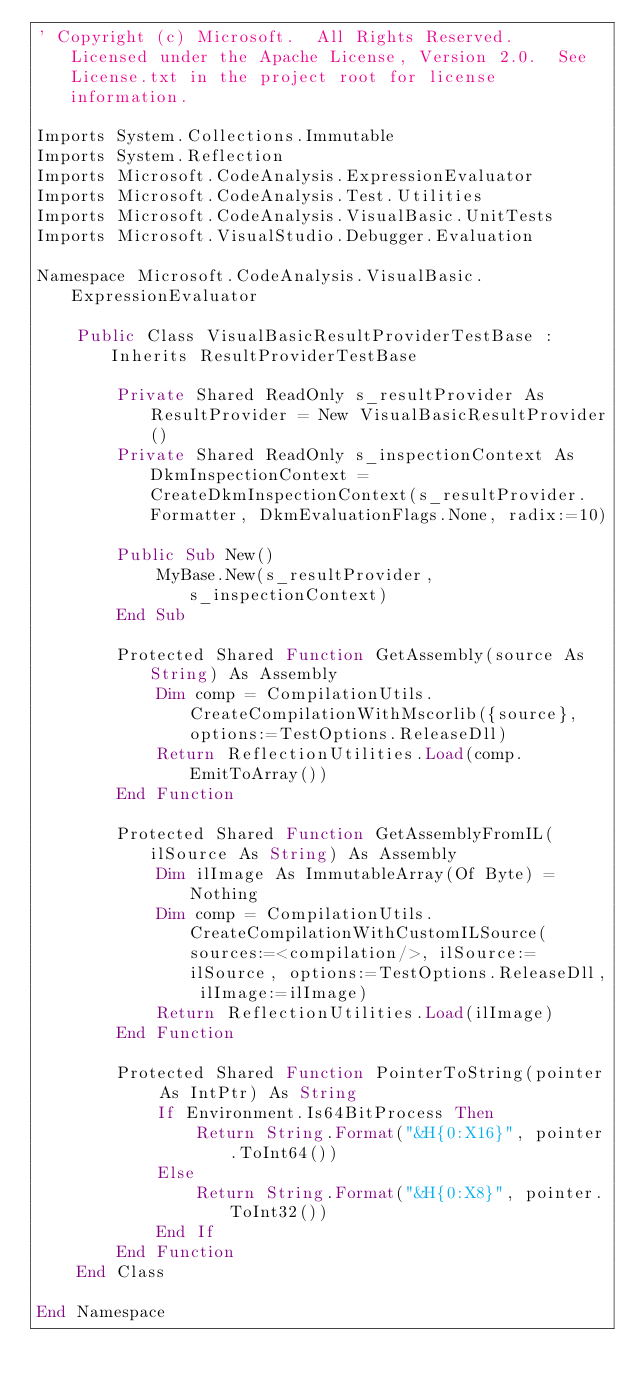Convert code to text. <code><loc_0><loc_0><loc_500><loc_500><_VisualBasic_>' Copyright (c) Microsoft.  All Rights Reserved.  Licensed under the Apache License, Version 2.0.  See License.txt in the project root for license information.

Imports System.Collections.Immutable
Imports System.Reflection
Imports Microsoft.CodeAnalysis.ExpressionEvaluator
Imports Microsoft.CodeAnalysis.Test.Utilities
Imports Microsoft.CodeAnalysis.VisualBasic.UnitTests
Imports Microsoft.VisualStudio.Debugger.Evaluation

Namespace Microsoft.CodeAnalysis.VisualBasic.ExpressionEvaluator

    Public Class VisualBasicResultProviderTestBase : Inherits ResultProviderTestBase

        Private Shared ReadOnly s_resultProvider As ResultProvider = New VisualBasicResultProvider()
        Private Shared ReadOnly s_inspectionContext As DkmInspectionContext = CreateDkmInspectionContext(s_resultProvider.Formatter, DkmEvaluationFlags.None, radix:=10)

        Public Sub New()
            MyBase.New(s_resultProvider, s_inspectionContext)
        End Sub

        Protected Shared Function GetAssembly(source As String) As Assembly
            Dim comp = CompilationUtils.CreateCompilationWithMscorlib({source}, options:=TestOptions.ReleaseDll)
            Return ReflectionUtilities.Load(comp.EmitToArray())
        End Function

        Protected Shared Function GetAssemblyFromIL(ilSource As String) As Assembly
            Dim ilImage As ImmutableArray(Of Byte) = Nothing
            Dim comp = CompilationUtils.CreateCompilationWithCustomILSource(sources:=<compilation/>, ilSource:=ilSource, options:=TestOptions.ReleaseDll, ilImage:=ilImage)
            Return ReflectionUtilities.Load(ilImage)
        End Function

        Protected Shared Function PointerToString(pointer As IntPtr) As String
            If Environment.Is64BitProcess Then
                Return String.Format("&H{0:X16}", pointer.ToInt64())
            Else
                Return String.Format("&H{0:X8}", pointer.ToInt32())
            End If
        End Function
    End Class

End Namespace</code> 